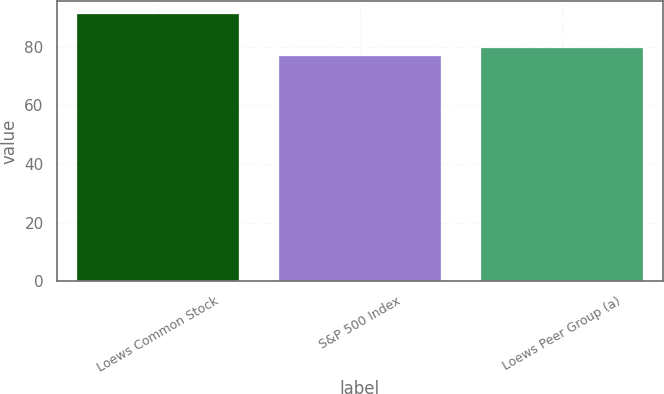Convert chart. <chart><loc_0><loc_0><loc_500><loc_500><bar_chart><fcel>Loews Common Stock<fcel>S&P 500 Index<fcel>Loews Peer Group (a)<nl><fcel>91.01<fcel>76.96<fcel>79.57<nl></chart> 